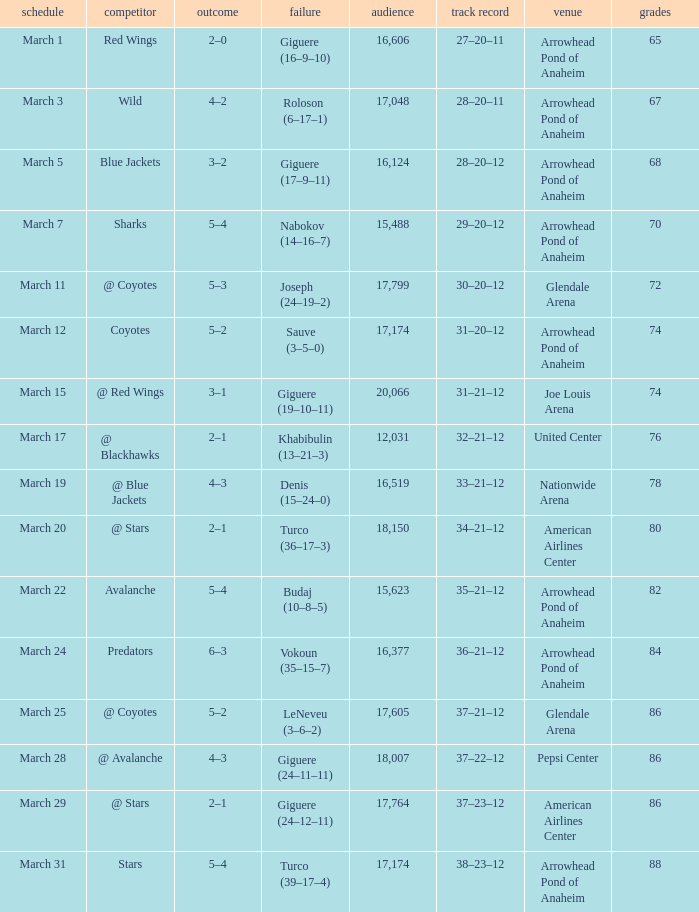What is the Attendance at Joe Louis Arena? 20066.0. Parse the full table. {'header': ['schedule', 'competitor', 'outcome', 'failure', 'audience', 'track record', 'venue', 'grades'], 'rows': [['March 1', 'Red Wings', '2–0', 'Giguere (16–9–10)', '16,606', '27–20–11', 'Arrowhead Pond of Anaheim', '65'], ['March 3', 'Wild', '4–2', 'Roloson (6–17–1)', '17,048', '28–20–11', 'Arrowhead Pond of Anaheim', '67'], ['March 5', 'Blue Jackets', '3–2', 'Giguere (17–9–11)', '16,124', '28–20–12', 'Arrowhead Pond of Anaheim', '68'], ['March 7', 'Sharks', '5–4', 'Nabokov (14–16–7)', '15,488', '29–20–12', 'Arrowhead Pond of Anaheim', '70'], ['March 11', '@ Coyotes', '5–3', 'Joseph (24–19–2)', '17,799', '30–20–12', 'Glendale Arena', '72'], ['March 12', 'Coyotes', '5–2', 'Sauve (3–5–0)', '17,174', '31–20–12', 'Arrowhead Pond of Anaheim', '74'], ['March 15', '@ Red Wings', '3–1', 'Giguere (19–10–11)', '20,066', '31–21–12', 'Joe Louis Arena', '74'], ['March 17', '@ Blackhawks', '2–1', 'Khabibulin (13–21–3)', '12,031', '32–21–12', 'United Center', '76'], ['March 19', '@ Blue Jackets', '4–3', 'Denis (15–24–0)', '16,519', '33–21–12', 'Nationwide Arena', '78'], ['March 20', '@ Stars', '2–1', 'Turco (36–17–3)', '18,150', '34–21–12', 'American Airlines Center', '80'], ['March 22', 'Avalanche', '5–4', 'Budaj (10–8–5)', '15,623', '35–21–12', 'Arrowhead Pond of Anaheim', '82'], ['March 24', 'Predators', '6–3', 'Vokoun (35–15–7)', '16,377', '36–21–12', 'Arrowhead Pond of Anaheim', '84'], ['March 25', '@ Coyotes', '5–2', 'LeNeveu (3–6–2)', '17,605', '37–21–12', 'Glendale Arena', '86'], ['March 28', '@ Avalanche', '4–3', 'Giguere (24–11–11)', '18,007', '37–22–12', 'Pepsi Center', '86'], ['March 29', '@ Stars', '2–1', 'Giguere (24–12–11)', '17,764', '37–23–12', 'American Airlines Center', '86'], ['March 31', 'Stars', '5–4', 'Turco (39–17–4)', '17,174', '38–23–12', 'Arrowhead Pond of Anaheim', '88']]} 